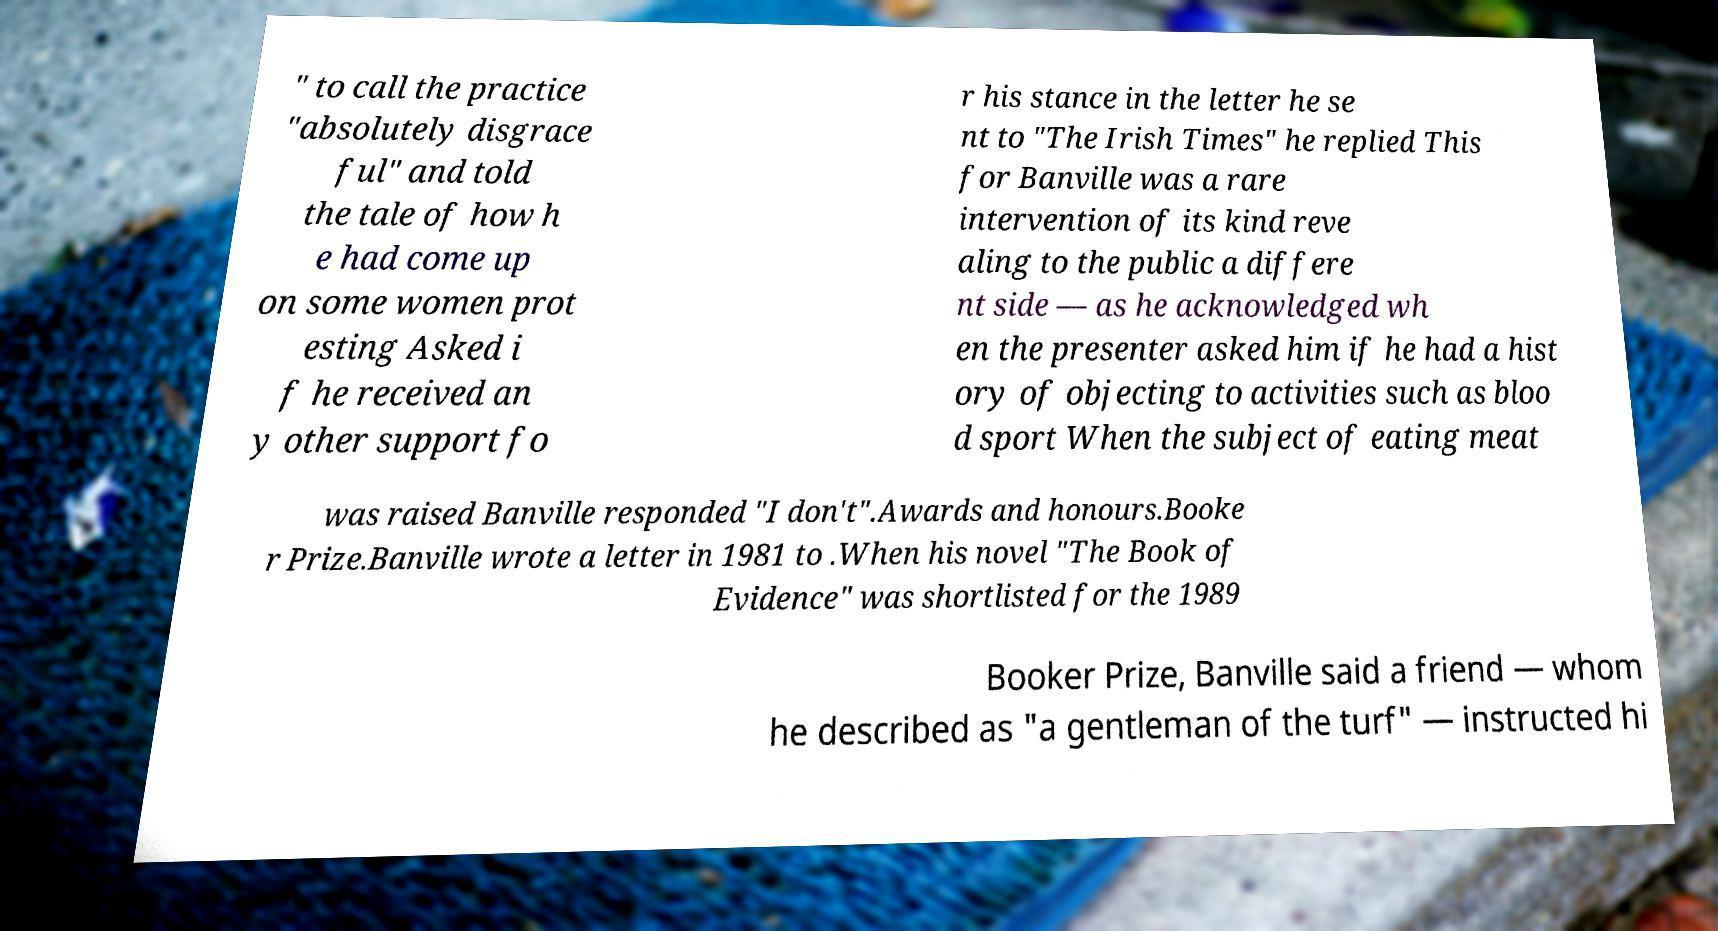There's text embedded in this image that I need extracted. Can you transcribe it verbatim? " to call the practice "absolutely disgrace ful" and told the tale of how h e had come up on some women prot esting Asked i f he received an y other support fo r his stance in the letter he se nt to "The Irish Times" he replied This for Banville was a rare intervention of its kind reve aling to the public a differe nt side — as he acknowledged wh en the presenter asked him if he had a hist ory of objecting to activities such as bloo d sport When the subject of eating meat was raised Banville responded "I don't".Awards and honours.Booke r Prize.Banville wrote a letter in 1981 to .When his novel "The Book of Evidence" was shortlisted for the 1989 Booker Prize, Banville said a friend — whom he described as "a gentleman of the turf" — instructed hi 